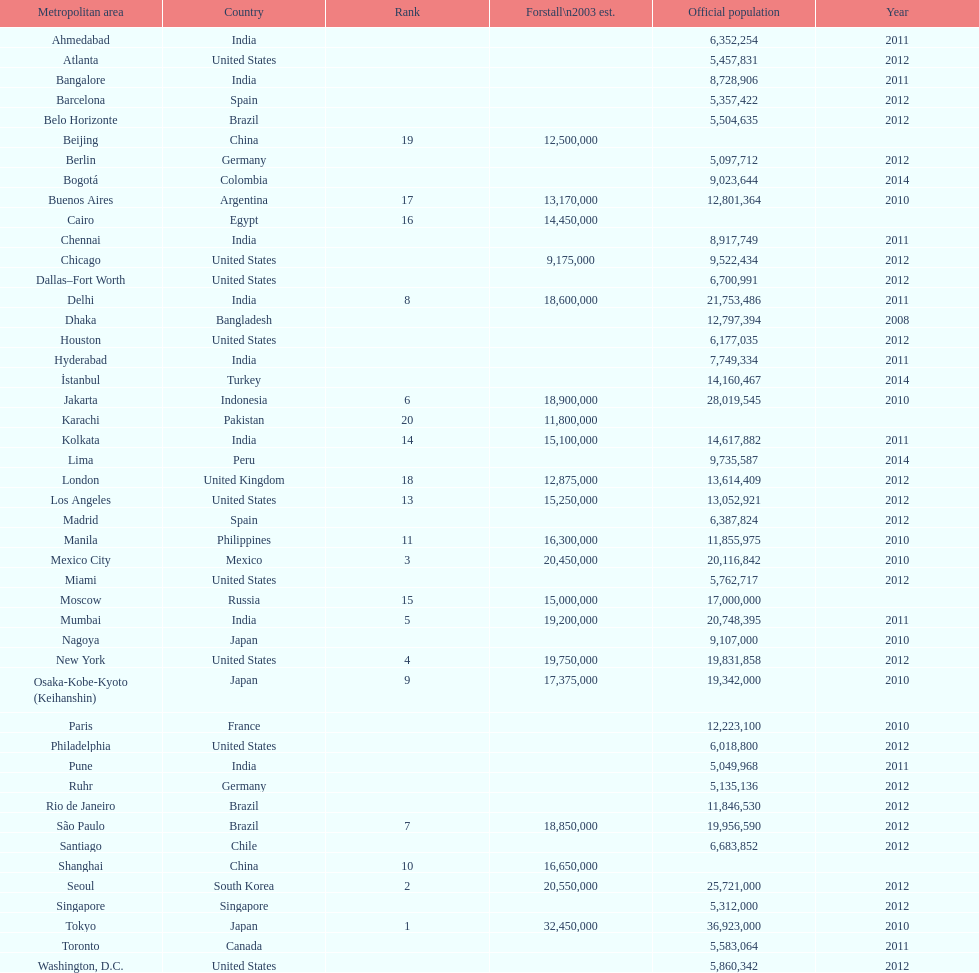In the united states, how many cities are there? 9. Give me the full table as a dictionary. {'header': ['Metropolitan area', 'Country', 'Rank', 'Forstall\\n2003 est.', 'Official population', 'Year'], 'rows': [['Ahmedabad', 'India', '', '', '6,352,254', '2011'], ['Atlanta', 'United States', '', '', '5,457,831', '2012'], ['Bangalore', 'India', '', '', '8,728,906', '2011'], ['Barcelona', 'Spain', '', '', '5,357,422', '2012'], ['Belo Horizonte', 'Brazil', '', '', '5,504,635', '2012'], ['Beijing', 'China', '19', '12,500,000', '', ''], ['Berlin', 'Germany', '', '', '5,097,712', '2012'], ['Bogotá', 'Colombia', '', '', '9,023,644', '2014'], ['Buenos Aires', 'Argentina', '17', '13,170,000', '12,801,364', '2010'], ['Cairo', 'Egypt', '16', '14,450,000', '', ''], ['Chennai', 'India', '', '', '8,917,749', '2011'], ['Chicago', 'United States', '', '9,175,000', '9,522,434', '2012'], ['Dallas–Fort Worth', 'United States', '', '', '6,700,991', '2012'], ['Delhi', 'India', '8', '18,600,000', '21,753,486', '2011'], ['Dhaka', 'Bangladesh', '', '', '12,797,394', '2008'], ['Houston', 'United States', '', '', '6,177,035', '2012'], ['Hyderabad', 'India', '', '', '7,749,334', '2011'], ['İstanbul', 'Turkey', '', '', '14,160,467', '2014'], ['Jakarta', 'Indonesia', '6', '18,900,000', '28,019,545', '2010'], ['Karachi', 'Pakistan', '20', '11,800,000', '', ''], ['Kolkata', 'India', '14', '15,100,000', '14,617,882', '2011'], ['Lima', 'Peru', '', '', '9,735,587', '2014'], ['London', 'United Kingdom', '18', '12,875,000', '13,614,409', '2012'], ['Los Angeles', 'United States', '13', '15,250,000', '13,052,921', '2012'], ['Madrid', 'Spain', '', '', '6,387,824', '2012'], ['Manila', 'Philippines', '11', '16,300,000', '11,855,975', '2010'], ['Mexico City', 'Mexico', '3', '20,450,000', '20,116,842', '2010'], ['Miami', 'United States', '', '', '5,762,717', '2012'], ['Moscow', 'Russia', '15', '15,000,000', '17,000,000', ''], ['Mumbai', 'India', '5', '19,200,000', '20,748,395', '2011'], ['Nagoya', 'Japan', '', '', '9,107,000', '2010'], ['New York', 'United States', '4', '19,750,000', '19,831,858', '2012'], ['Osaka-Kobe-Kyoto (Keihanshin)', 'Japan', '9', '17,375,000', '19,342,000', '2010'], ['Paris', 'France', '', '', '12,223,100', '2010'], ['Philadelphia', 'United States', '', '', '6,018,800', '2012'], ['Pune', 'India', '', '', '5,049,968', '2011'], ['Ruhr', 'Germany', '', '', '5,135,136', '2012'], ['Rio de Janeiro', 'Brazil', '', '', '11,846,530', '2012'], ['São Paulo', 'Brazil', '7', '18,850,000', '19,956,590', '2012'], ['Santiago', 'Chile', '', '', '6,683,852', '2012'], ['Shanghai', 'China', '10', '16,650,000', '', ''], ['Seoul', 'South Korea', '2', '20,550,000', '25,721,000', '2012'], ['Singapore', 'Singapore', '', '', '5,312,000', '2012'], ['Tokyo', 'Japan', '1', '32,450,000', '36,923,000', '2010'], ['Toronto', 'Canada', '', '', '5,583,064', '2011'], ['Washington, D.C.', 'United States', '', '', '5,860,342', '2012']]} 